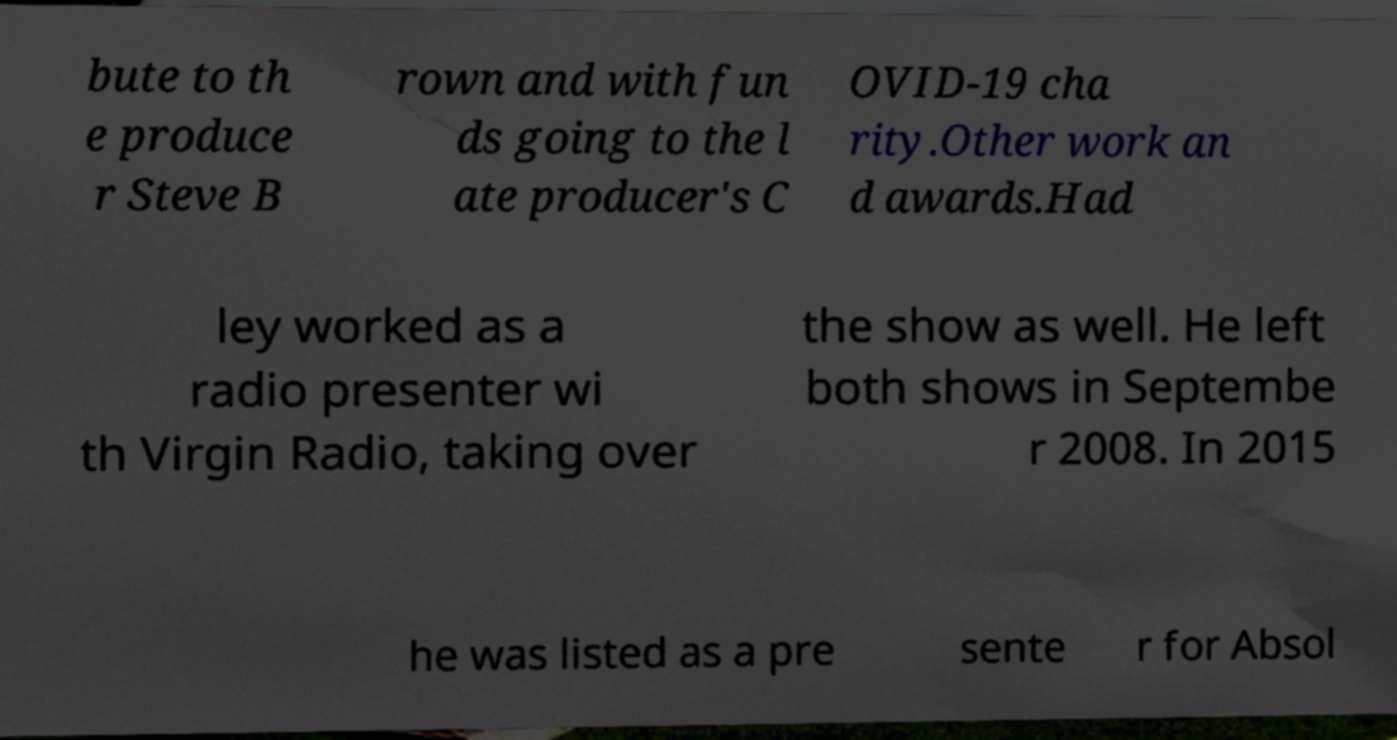Could you assist in decoding the text presented in this image and type it out clearly? bute to th e produce r Steve B rown and with fun ds going to the l ate producer's C OVID-19 cha rity.Other work an d awards.Had ley worked as a radio presenter wi th Virgin Radio, taking over the show as well. He left both shows in Septembe r 2008. In 2015 he was listed as a pre sente r for Absol 